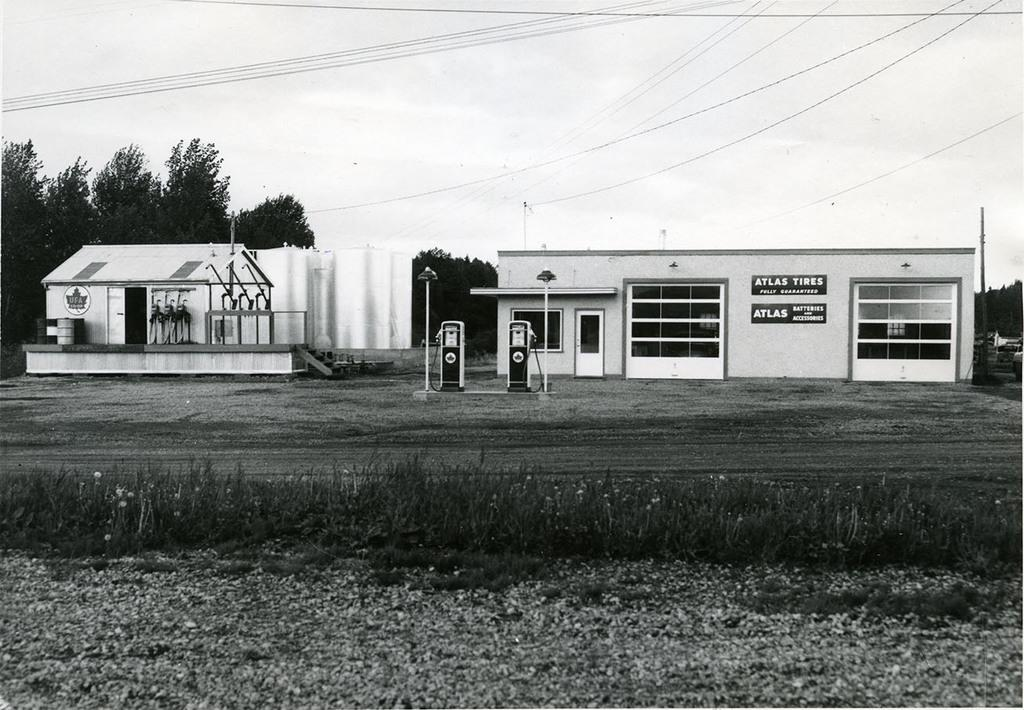What is located in the center of the image? There are buildings in the center of the image. What type of vegetation can be seen at the bottom of the image? There is grass at the bottom of the image. What can be seen in the background of the image? There are trees, wires, and the sky visible in the background of the image. What structures are present in the image? There are poles present in the image. How many beams are supporting the room in the image? There is no room present in the image, so there are no beams supporting it. What type of fruit can be seen being crushed by the wires in the image? There is no fruit being crushed by the wires in the image; the wires are simply present in the background. 